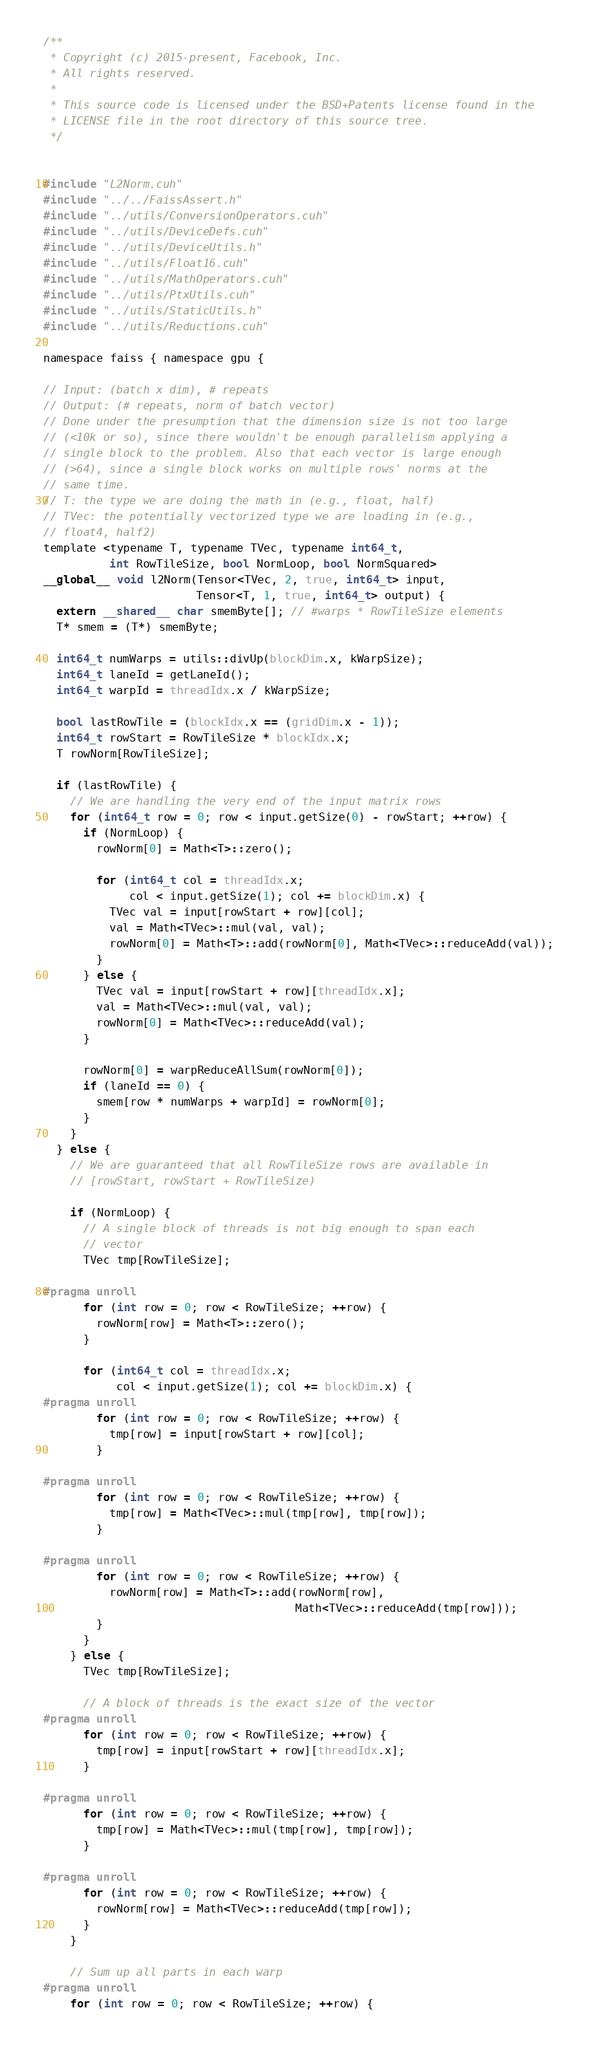Convert code to text. <code><loc_0><loc_0><loc_500><loc_500><_Cuda_>/**
 * Copyright (c) 2015-present, Facebook, Inc.
 * All rights reserved.
 *
 * This source code is licensed under the BSD+Patents license found in the
 * LICENSE file in the root directory of this source tree.
 */


#include "L2Norm.cuh"
#include "../../FaissAssert.h"
#include "../utils/ConversionOperators.cuh"
#include "../utils/DeviceDefs.cuh"
#include "../utils/DeviceUtils.h"
#include "../utils/Float16.cuh"
#include "../utils/MathOperators.cuh"
#include "../utils/PtxUtils.cuh"
#include "../utils/StaticUtils.h"
#include "../utils/Reductions.cuh"

namespace faiss { namespace gpu {

// Input: (batch x dim), # repeats
// Output: (# repeats, norm of batch vector)
// Done under the presumption that the dimension size is not too large
// (<10k or so), since there wouldn't be enough parallelism applying a
// single block to the problem. Also that each vector is large enough
// (>64), since a single block works on multiple rows' norms at the
// same time.
// T: the type we are doing the math in (e.g., float, half)
// TVec: the potentially vectorized type we are loading in (e.g.,
// float4, half2)
template <typename T, typename TVec, typename int64_t,
          int RowTileSize, bool NormLoop, bool NormSquared>
__global__ void l2Norm(Tensor<TVec, 2, true, int64_t> input,
                       Tensor<T, 1, true, int64_t> output) {
  extern __shared__ char smemByte[]; // #warps * RowTileSize elements
  T* smem = (T*) smemByte;

  int64_t numWarps = utils::divUp(blockDim.x, kWarpSize);
  int64_t laneId = getLaneId();
  int64_t warpId = threadIdx.x / kWarpSize;

  bool lastRowTile = (blockIdx.x == (gridDim.x - 1));
  int64_t rowStart = RowTileSize * blockIdx.x;
  T rowNorm[RowTileSize];

  if (lastRowTile) {
    // We are handling the very end of the input matrix rows
    for (int64_t row = 0; row < input.getSize(0) - rowStart; ++row) {
      if (NormLoop) {
        rowNorm[0] = Math<T>::zero();

        for (int64_t col = threadIdx.x;
             col < input.getSize(1); col += blockDim.x) {
          TVec val = input[rowStart + row][col];
          val = Math<TVec>::mul(val, val);
          rowNorm[0] = Math<T>::add(rowNorm[0], Math<TVec>::reduceAdd(val));
        }
      } else {
        TVec val = input[rowStart + row][threadIdx.x];
        val = Math<TVec>::mul(val, val);
        rowNorm[0] = Math<TVec>::reduceAdd(val);
      }

      rowNorm[0] = warpReduceAllSum(rowNorm[0]);
      if (laneId == 0) {
        smem[row * numWarps + warpId] = rowNorm[0];
      }
    }
  } else {
    // We are guaranteed that all RowTileSize rows are available in
    // [rowStart, rowStart + RowTileSize)

    if (NormLoop) {
      // A single block of threads is not big enough to span each
      // vector
      TVec tmp[RowTileSize];

#pragma unroll
      for (int row = 0; row < RowTileSize; ++row) {
        rowNorm[row] = Math<T>::zero();
      }

      for (int64_t col = threadIdx.x;
           col < input.getSize(1); col += blockDim.x) {
#pragma unroll
        for (int row = 0; row < RowTileSize; ++row) {
          tmp[row] = input[rowStart + row][col];
        }

#pragma unroll
        for (int row = 0; row < RowTileSize; ++row) {
          tmp[row] = Math<TVec>::mul(tmp[row], tmp[row]);
        }

#pragma unroll
        for (int row = 0; row < RowTileSize; ++row) {
          rowNorm[row] = Math<T>::add(rowNorm[row],
                                      Math<TVec>::reduceAdd(tmp[row]));
        }
      }
    } else {
      TVec tmp[RowTileSize];

      // A block of threads is the exact size of the vector
#pragma unroll
      for (int row = 0; row < RowTileSize; ++row) {
        tmp[row] = input[rowStart + row][threadIdx.x];
      }

#pragma unroll
      for (int row = 0; row < RowTileSize; ++row) {
        tmp[row] = Math<TVec>::mul(tmp[row], tmp[row]);
      }

#pragma unroll
      for (int row = 0; row < RowTileSize; ++row) {
        rowNorm[row] = Math<TVec>::reduceAdd(tmp[row]);
      }
    }

    // Sum up all parts in each warp
#pragma unroll
    for (int row = 0; row < RowTileSize; ++row) {</code> 